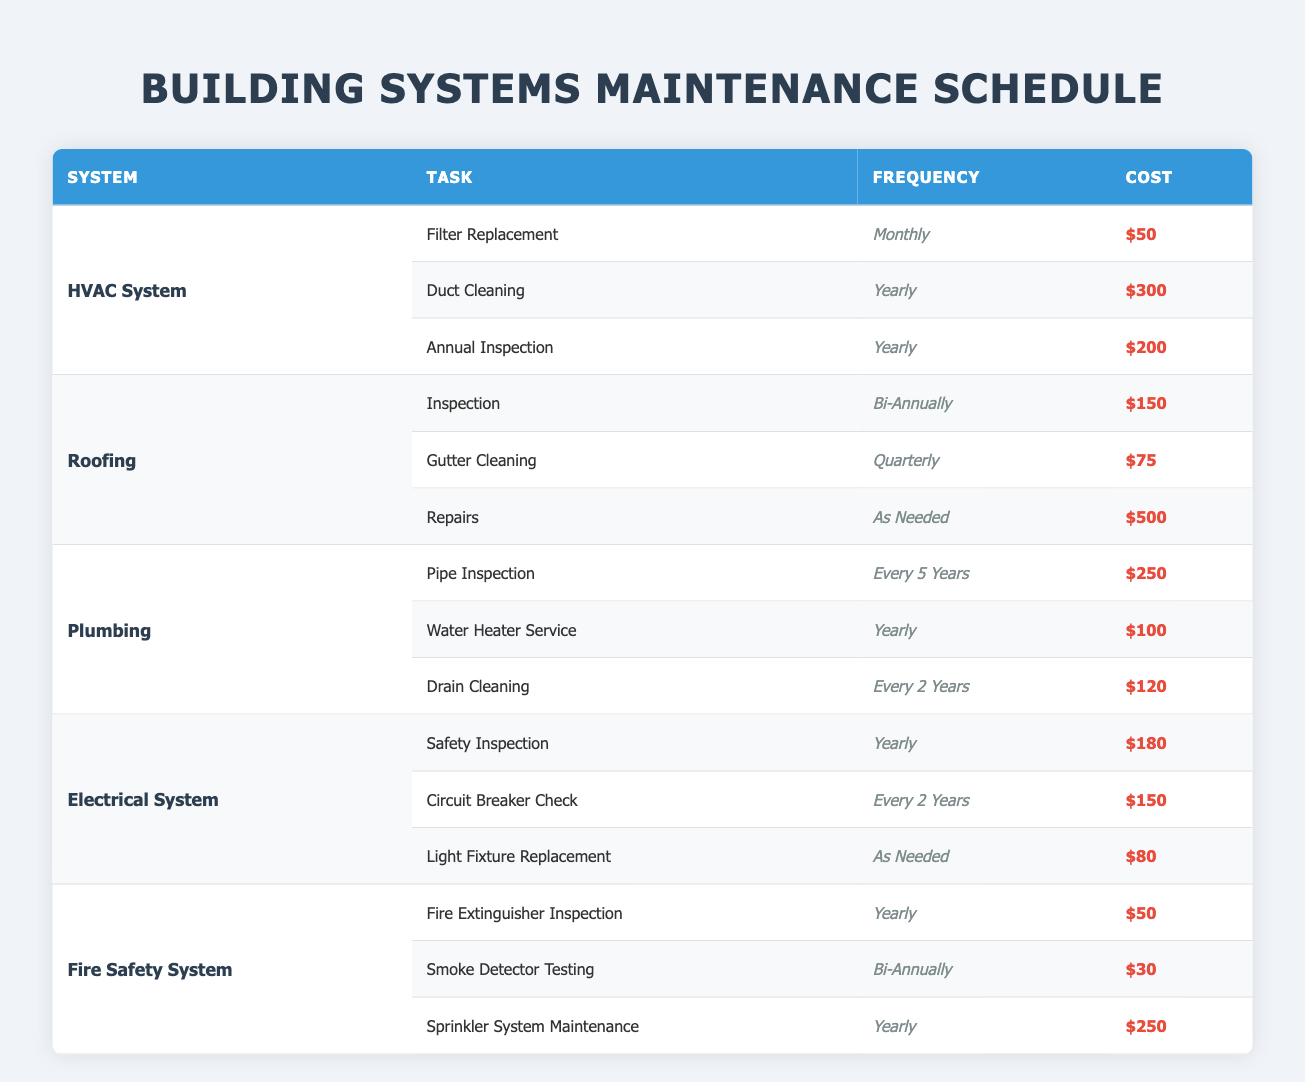What is the cost of the annual inspection for the HVAC System? The table indicates that the task "Annual Inspection" for the HVAC System has a listed cost of $200.
Answer: $200 How often does the Electrical System require a safety inspection? According to the table, the safety inspection for the Electrical System is required yearly.
Answer: Yearly What is the total cost of maintenance tasks for the Roofing system? The tasks for Roofing are: Inspection ($150), Gutter Cleaning ($75), and Repairs ($500). The total cost is $150 + $75 + $500 = $725.
Answer: $725 Is the frequency for pipe inspection the same as for drain cleaning in the Plumbing system? The table shows that pipe inspection occurs every 5 years, while drain cleaning occurs every 2 years; hence, the frequencies are not the same.
Answer: No What is the average cost of maintenance tasks for the Fire Safety System? The costs for the Fire Safety System are: Fire Extinguisher Inspection ($50), Smoke Detector Testing ($30), and Sprinkler System Maintenance ($250). The average is calculated as ($50 + $30 + $250) / 3 = $110.
Answer: $110 Which building system has the highest single maintenance cost, and what is that cost? The table reveals that the "Repairs" task in the Roofing system has the highest single maintenance cost of $500.
Answer: Roofing System, $500 How many maintenance tasks in total are listed for the Plumbing system? The Plumbing system has three maintenance tasks: Pipe Inspection, Water Heater Service, and Drain Cleaning, making the total count three tasks.
Answer: 3 Calculate the total maintenance cost for the HVAC System over a year. Over a year, the costs for the HVAC System tasks are: Filter Replacement (12 months x $50 = $600), Duct Cleaning ($300), and Annual Inspection ($200). Total cost is $600 + $300 + $200 = $1100.
Answer: $1100 Which maintenance task for the Electrical System occurs the least frequently, and how often is it performed? The task "Circuit Breaker Check" occurs every 2 years, making it the least frequent task in the Electrical System as other tasks are yearly or as needed.
Answer: Every 2 years What is the total maintenance cost for all systems combined? The total costs for each system are: HVAC ($1100), Roofing ($725), Plumbing ($490), Electrical ($410), and Fire Safety ($330). The combined total is $1100 + $725 + $490 + $410 + $330 = $3055.
Answer: $3055 